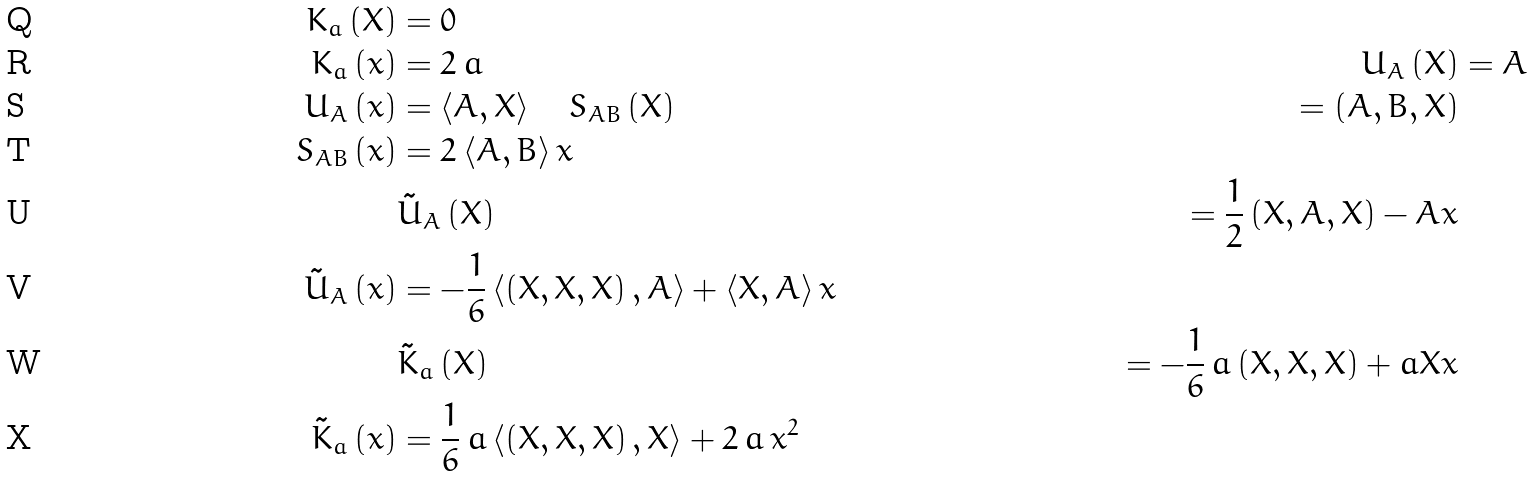<formula> <loc_0><loc_0><loc_500><loc_500>K _ { a } \left ( X \right ) & = 0 \\ K _ { a } \left ( x \right ) & = 2 \, a & \quad U _ { A } \left ( X \right ) & = A \\ U _ { A } \left ( x \right ) & = \left < A , X \right > \quad S _ { A B } \left ( X \right ) & = \left ( A , B , X \right ) \\ S _ { A B } \left ( x \right ) & = 2 \left < A , B \right > x \\ & \tilde { U } _ { A } \left ( X \right ) & = \frac { 1 } { 2 } \left ( X , A , X \right ) - A x \\ \tilde { U } _ { A } \left ( x \right ) & = - \frac { 1 } { 6 } \left < \left ( X , X , X \right ) , A \right > + \left < X , A \right > x \\ & \tilde { K } _ { a } \left ( X \right ) & = - \frac { 1 } { 6 } \, a \left ( X , X , X \right ) + a X x \\ \tilde { K } _ { a } \left ( x \right ) & = \frac { 1 } { 6 } \, a \left < \left ( X , X , X \right ) , X \right > + 2 \, a \, x ^ { 2 }</formula> 